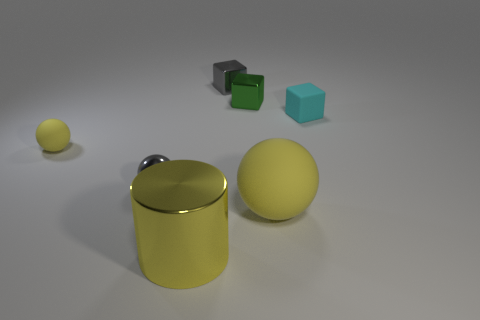There is a matte object that is on the right side of the big cylinder and to the left of the cyan object; what is its shape?
Keep it short and to the point. Sphere. What is the material of the yellow sphere that is behind the gray thing to the left of the large metal object?
Give a very brief answer. Rubber. Are there more large gray cylinders than tiny yellow rubber things?
Provide a short and direct response. No. Do the metal cylinder and the big ball have the same color?
Provide a succinct answer. Yes. What is the material of the green cube that is the same size as the gray sphere?
Provide a succinct answer. Metal. Are the green object and the big cylinder made of the same material?
Give a very brief answer. Yes. How many tiny gray blocks have the same material as the large cylinder?
Make the answer very short. 1. How many objects are either matte spheres to the right of the metallic cylinder or yellow balls behind the metallic ball?
Make the answer very short. 2. Is the number of matte cubes on the left side of the tiny rubber block greater than the number of yellow spheres in front of the gray ball?
Provide a succinct answer. No. The large thing that is behind the large yellow cylinder is what color?
Offer a terse response. Yellow. 